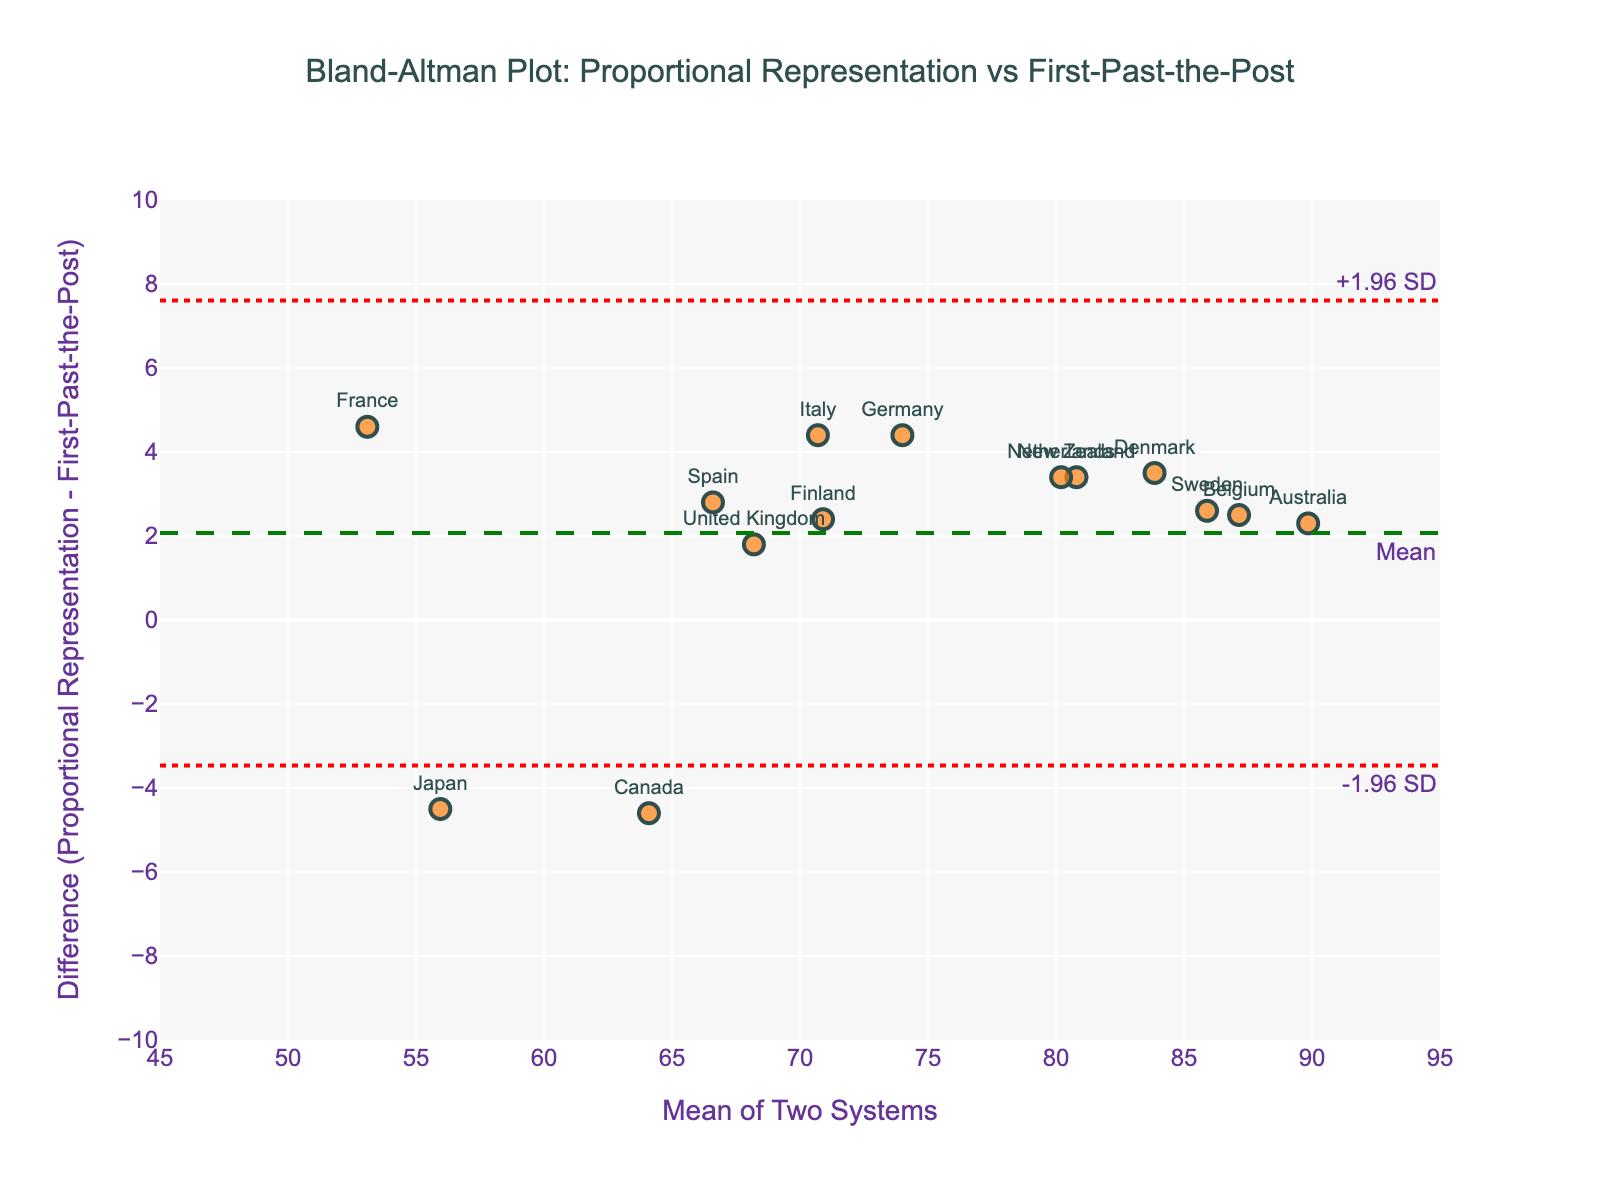How many countries are included in this plot? Count the number of data points (markers) and country labels in the plot.
Answer: 14 Which country shows the largest positive difference between the two electoral systems? Identify the data point highest above the zero-difference line, and read the corresponding country label.
Answer: Japan What is the mean difference between voter turnout rates for the two electoral systems? Locate the green dashed line and check its annotation for the mean difference value.
Answer: Approximately 1.7 What are the limits of agreement for the voter turnout rates? Locate the red dotted lines and their annotations for the upper and lower 1.96 standard deviations from the mean difference.
Answer: +4.89 and -1.49 What is the average voter turnout rate for Germany according to the plot? Identify the marker for Germany, then check the x-axis value (mean of the two systems) for Germany.
Answer: 74.0 Which country has the highest voter turnout mean in both systems according to the plot? Identify the marker farthest to the right on the x-axis and read its country label.
Answer: Australia Does any country fall outside the limits of agreement in the plot? Check if any markers lie above the upper limit or below the lower limit lines.
Answer: No Which electoral system generally results in higher voter turnout based on the mean difference? Assess whether most data points lie above or below the zero-difference line, and compare the mean difference line relative to zero.
Answer: First-Past-the-Post What is the voter turnout difference between Proportional Representation and First-Past-the-Post for Canada? Identify the marker for Canada and read its y-axis value for the difference.
Answer: Approximately -4.6 Are the differences between voter turnout rates normally distributed around the mean difference? Evaluate if the data points' spread around the mean difference line appears symmetrical and evenly distributed.
Answer: Yes 